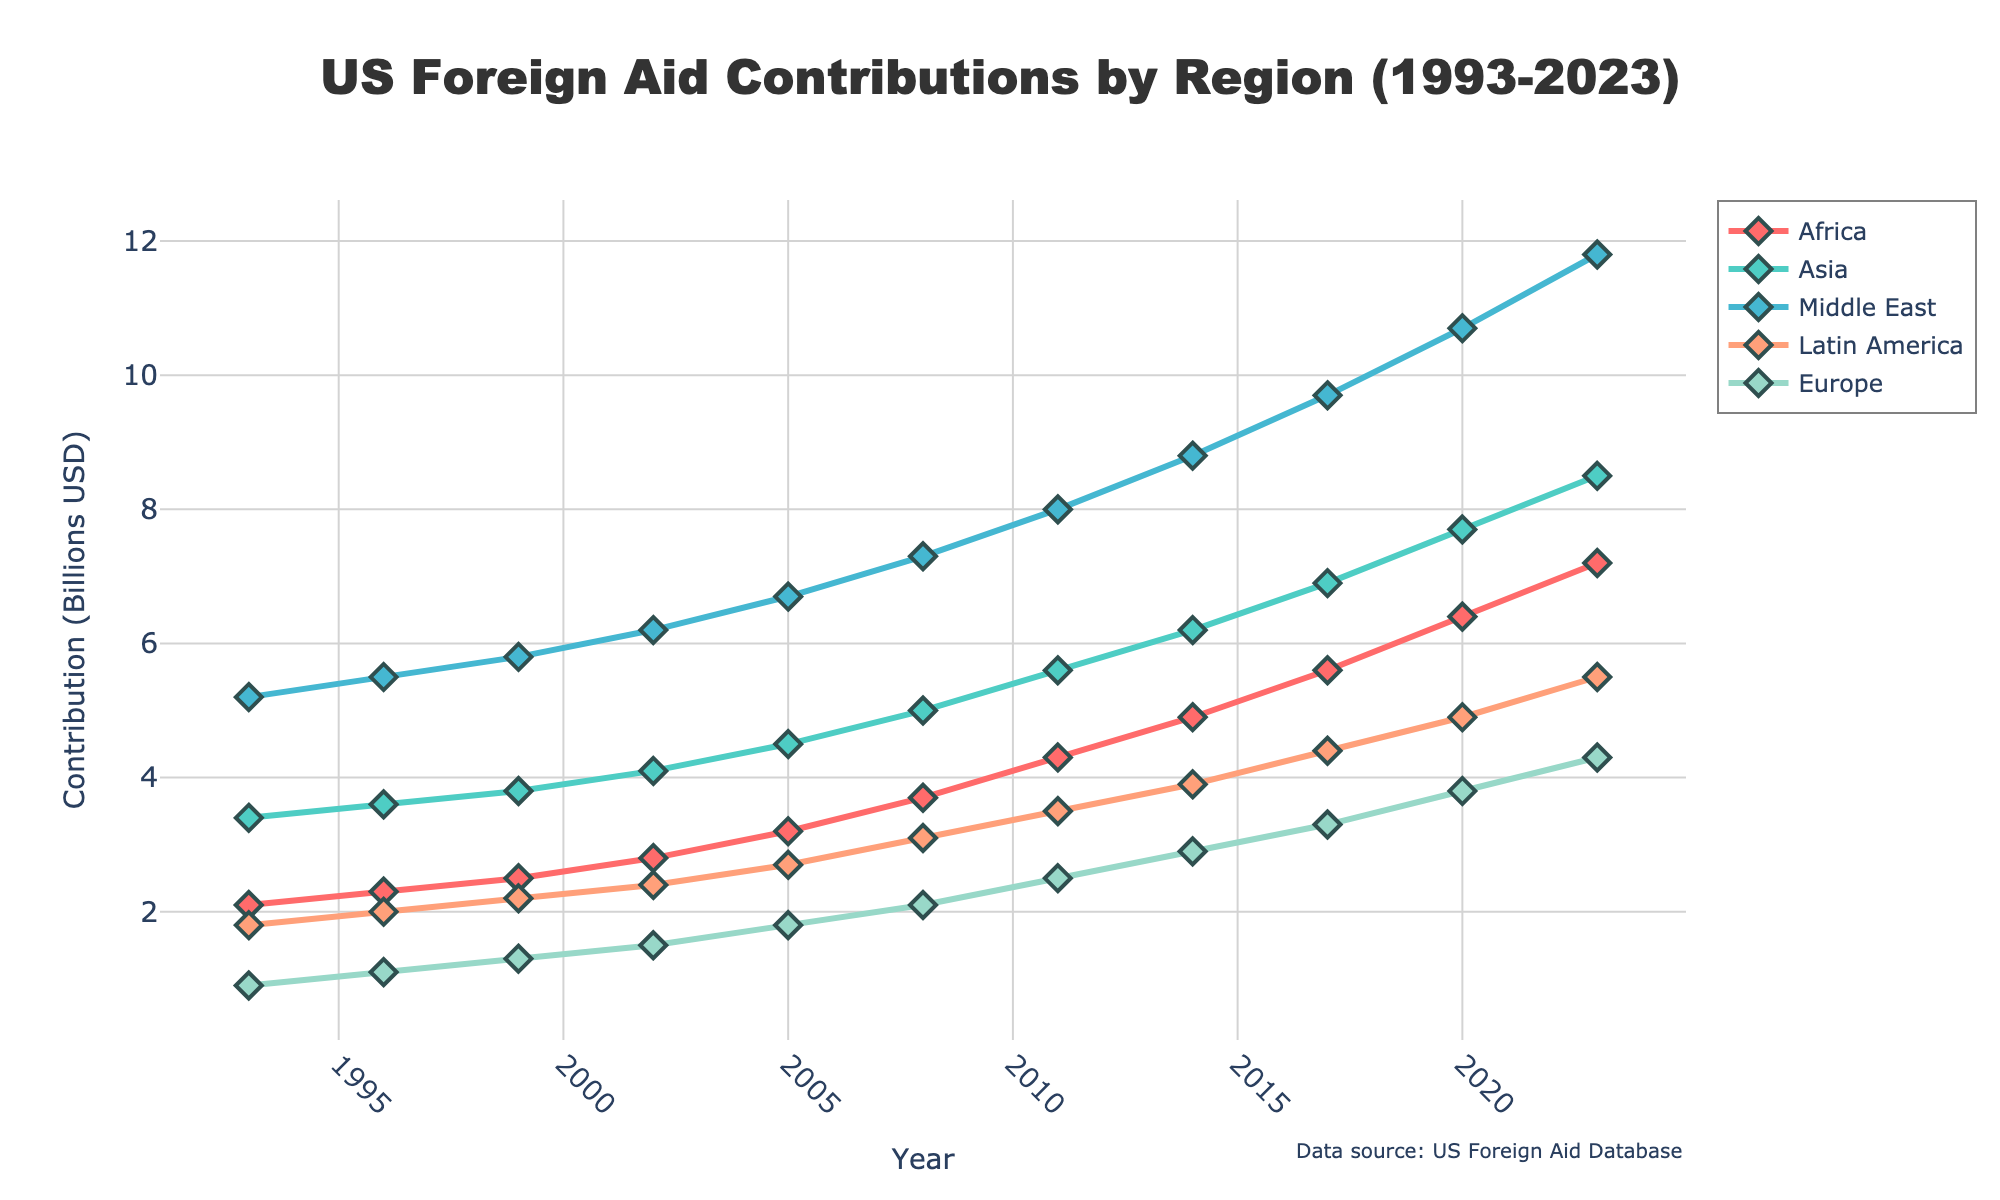What is the overall trend in foreign aid contributions to Africa from 1993 to 2023? From 1993 to 2023, the foreign aid contributions to Africa have steadily increased from 2.1 billion USD to 7.2 billion USD. This shows a clear upward trend over the years.
Answer: The contributions have increased Which region received the highest foreign aid in 2023? In 2023, the Middle East received the highest foreign aid among all regions. By inspecting the height of the lines in the figure, it's clear that the Middle East's line is at the highest point on the y-axis.
Answer: Middle East How did the contributions to Europe change over the 30 years? Looking at the line for Europe, it started at 0.9 billion USD in 1993 and has gradually increased to 4.3 billion USD by 2023. The trend shows a steady increase over the period.
Answer: It increased What is the total foreign aid contribution to all regions combined in 2023? Summing up the contributions in 2023: Africa (7.2) + Asia (8.5) + Middle East (11.8) + Latin America (5.5) + Europe (4.3) = 37.3 billion USD.
Answer: 37.3 billion USD Which region had the smallest increase in foreign aid contributions from 1993 to 2023? By looking at the starting and ending points of each line, Europe had the smallest increase. Europe increased from 0.9 billion USD in 1993 to 4.3 billion USD in 2023, an increase of 3.4 billion USD.
Answer: Europe In which year did Asia receive the smallest amount of foreign aid, and what was that amount? From the initial part of the line for Asia, the smallest amount was in 1993, with a contribution of 3.4 billion USD.
Answer: 1993, 3.4 billion USD Compare the foreign aid given to the Middle East and Latin America over the 30 years. Which region has seen the steeper increase? The Middle East started at 5.2 billion USD in 1993 and went to 11.8 billion USD in 2023, while Latin America started at 1.8 billion USD in 1993 and went to 5.5 billion USD in 2023. The Middle East had a larger absolute increase and a steeper slope in the figure.
Answer: Middle East What is the total foreign aid given to Asia over the period from 1993 to 2023? To find this, sum the contributions for Asia at all listed years: 3.4 + 3.6 + 3.8 + 4.1 + 4.5 + 5.0 + 5.6 + 6.2 + 6.9 + 7.7 + 8.5 = 59.3 billion USD.
Answer: 59.3 billion USD What is the average foreign aid contribution to Latin America from 1993 to 2023? Sum up the contributions for Latin America and then divide by the number of years: (1.8 + 2.0 + 2.2 + 2.4 + 2.7 + 3.1 + 3.5 + 3.9 + 4.4 + 4.9 + 5.5) / 11 = 36 / 11 ≈ 3.27 billion USD.
Answer: ≈ 3.27 billion USD 